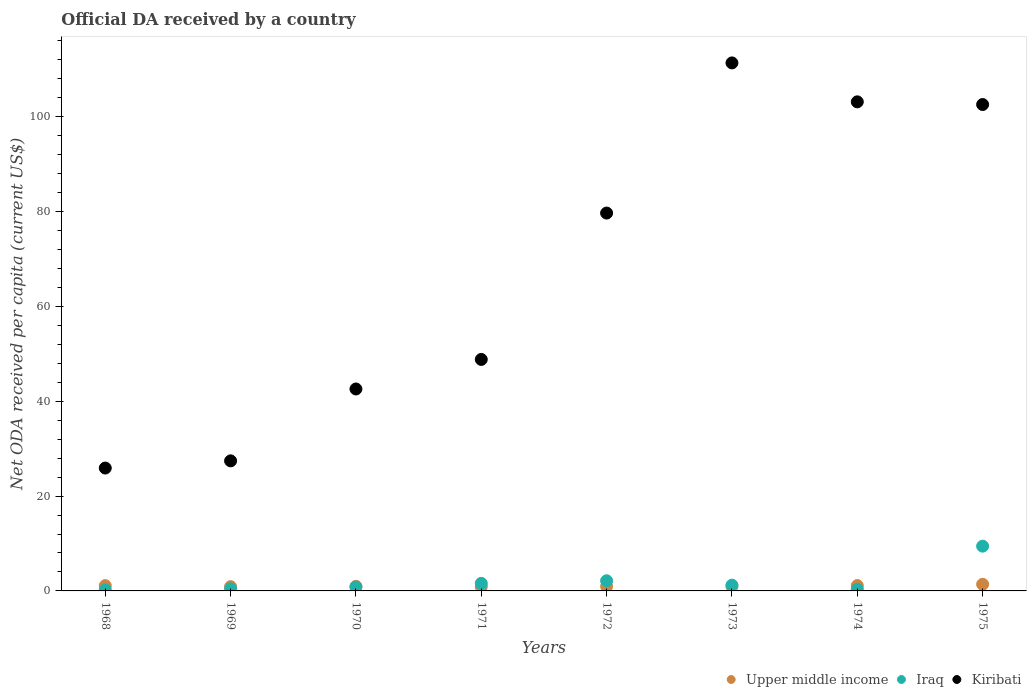How many different coloured dotlines are there?
Your response must be concise. 3. What is the ODA received in in Upper middle income in 1975?
Your response must be concise. 1.39. Across all years, what is the maximum ODA received in in Iraq?
Your response must be concise. 9.44. Across all years, what is the minimum ODA received in in Iraq?
Offer a terse response. 0.25. In which year was the ODA received in in Iraq maximum?
Your answer should be very brief. 1975. In which year was the ODA received in in Iraq minimum?
Your answer should be very brief. 1968. What is the total ODA received in in Kiribati in the graph?
Offer a very short reply. 541.6. What is the difference between the ODA received in in Iraq in 1971 and that in 1975?
Keep it short and to the point. -7.85. What is the difference between the ODA received in in Upper middle income in 1971 and the ODA received in in Kiribati in 1974?
Provide a succinct answer. -102.26. What is the average ODA received in in Upper middle income per year?
Offer a very short reply. 1.04. In the year 1968, what is the difference between the ODA received in in Kiribati and ODA received in in Iraq?
Provide a short and direct response. 25.67. In how many years, is the ODA received in in Iraq greater than 28 US$?
Ensure brevity in your answer.  0. What is the ratio of the ODA received in in Kiribati in 1969 to that in 1973?
Offer a terse response. 0.25. Is the ODA received in in Iraq in 1972 less than that in 1974?
Make the answer very short. No. What is the difference between the highest and the second highest ODA received in in Upper middle income?
Ensure brevity in your answer.  0.26. What is the difference between the highest and the lowest ODA received in in Kiribati?
Keep it short and to the point. 85.45. Does the ODA received in in Upper middle income monotonically increase over the years?
Provide a succinct answer. No. Is the ODA received in in Kiribati strictly greater than the ODA received in in Iraq over the years?
Provide a short and direct response. Yes. How many dotlines are there?
Give a very brief answer. 3. What is the difference between two consecutive major ticks on the Y-axis?
Your answer should be very brief. 20. Does the graph contain grids?
Offer a very short reply. No. Where does the legend appear in the graph?
Provide a succinct answer. Bottom right. How are the legend labels stacked?
Your answer should be compact. Horizontal. What is the title of the graph?
Ensure brevity in your answer.  Official DA received by a country. Does "Turkey" appear as one of the legend labels in the graph?
Ensure brevity in your answer.  No. What is the label or title of the X-axis?
Offer a terse response. Years. What is the label or title of the Y-axis?
Your answer should be compact. Net ODA received per capita (current US$). What is the Net ODA received per capita (current US$) of Upper middle income in 1968?
Your answer should be very brief. 1.12. What is the Net ODA received per capita (current US$) in Iraq in 1968?
Your answer should be compact. 0.25. What is the Net ODA received per capita (current US$) in Kiribati in 1968?
Keep it short and to the point. 25.92. What is the Net ODA received per capita (current US$) in Upper middle income in 1969?
Provide a succinct answer. 0.9. What is the Net ODA received per capita (current US$) in Iraq in 1969?
Your answer should be compact. 0.45. What is the Net ODA received per capita (current US$) of Kiribati in 1969?
Offer a terse response. 27.43. What is the Net ODA received per capita (current US$) in Upper middle income in 1970?
Provide a short and direct response. 0.97. What is the Net ODA received per capita (current US$) in Iraq in 1970?
Make the answer very short. 0.81. What is the Net ODA received per capita (current US$) in Kiribati in 1970?
Ensure brevity in your answer.  42.59. What is the Net ODA received per capita (current US$) in Upper middle income in 1971?
Keep it short and to the point. 0.9. What is the Net ODA received per capita (current US$) of Iraq in 1971?
Make the answer very short. 1.6. What is the Net ODA received per capita (current US$) in Kiribati in 1971?
Provide a short and direct response. 48.83. What is the Net ODA received per capita (current US$) in Upper middle income in 1972?
Give a very brief answer. 0.96. What is the Net ODA received per capita (current US$) of Iraq in 1972?
Offer a very short reply. 2.14. What is the Net ODA received per capita (current US$) in Kiribati in 1972?
Your answer should be very brief. 79.7. What is the Net ODA received per capita (current US$) in Upper middle income in 1973?
Provide a short and direct response. 0.96. What is the Net ODA received per capita (current US$) in Iraq in 1973?
Ensure brevity in your answer.  1.21. What is the Net ODA received per capita (current US$) in Kiribati in 1973?
Make the answer very short. 111.37. What is the Net ODA received per capita (current US$) in Upper middle income in 1974?
Your answer should be very brief. 1.13. What is the Net ODA received per capita (current US$) of Iraq in 1974?
Keep it short and to the point. 0.37. What is the Net ODA received per capita (current US$) in Kiribati in 1974?
Keep it short and to the point. 103.16. What is the Net ODA received per capita (current US$) of Upper middle income in 1975?
Your response must be concise. 1.39. What is the Net ODA received per capita (current US$) of Iraq in 1975?
Your response must be concise. 9.44. What is the Net ODA received per capita (current US$) of Kiribati in 1975?
Offer a terse response. 102.59. Across all years, what is the maximum Net ODA received per capita (current US$) in Upper middle income?
Provide a succinct answer. 1.39. Across all years, what is the maximum Net ODA received per capita (current US$) of Iraq?
Keep it short and to the point. 9.44. Across all years, what is the maximum Net ODA received per capita (current US$) in Kiribati?
Your answer should be compact. 111.37. Across all years, what is the minimum Net ODA received per capita (current US$) of Upper middle income?
Provide a succinct answer. 0.9. Across all years, what is the minimum Net ODA received per capita (current US$) in Iraq?
Ensure brevity in your answer.  0.25. Across all years, what is the minimum Net ODA received per capita (current US$) in Kiribati?
Your response must be concise. 25.92. What is the total Net ODA received per capita (current US$) of Upper middle income in the graph?
Your answer should be very brief. 8.32. What is the total Net ODA received per capita (current US$) of Iraq in the graph?
Your answer should be compact. 16.28. What is the total Net ODA received per capita (current US$) in Kiribati in the graph?
Provide a short and direct response. 541.6. What is the difference between the Net ODA received per capita (current US$) of Upper middle income in 1968 and that in 1969?
Keep it short and to the point. 0.22. What is the difference between the Net ODA received per capita (current US$) in Iraq in 1968 and that in 1969?
Ensure brevity in your answer.  -0.2. What is the difference between the Net ODA received per capita (current US$) of Kiribati in 1968 and that in 1969?
Provide a short and direct response. -1.52. What is the difference between the Net ODA received per capita (current US$) in Upper middle income in 1968 and that in 1970?
Ensure brevity in your answer.  0.15. What is the difference between the Net ODA received per capita (current US$) of Iraq in 1968 and that in 1970?
Give a very brief answer. -0.57. What is the difference between the Net ODA received per capita (current US$) of Kiribati in 1968 and that in 1970?
Your response must be concise. -16.68. What is the difference between the Net ODA received per capita (current US$) of Upper middle income in 1968 and that in 1971?
Give a very brief answer. 0.22. What is the difference between the Net ODA received per capita (current US$) of Iraq in 1968 and that in 1971?
Ensure brevity in your answer.  -1.35. What is the difference between the Net ODA received per capita (current US$) of Kiribati in 1968 and that in 1971?
Offer a very short reply. -22.91. What is the difference between the Net ODA received per capita (current US$) in Upper middle income in 1968 and that in 1972?
Provide a short and direct response. 0.16. What is the difference between the Net ODA received per capita (current US$) of Iraq in 1968 and that in 1972?
Offer a terse response. -1.9. What is the difference between the Net ODA received per capita (current US$) of Kiribati in 1968 and that in 1972?
Your answer should be very brief. -53.78. What is the difference between the Net ODA received per capita (current US$) of Upper middle income in 1968 and that in 1973?
Your answer should be very brief. 0.16. What is the difference between the Net ODA received per capita (current US$) in Iraq in 1968 and that in 1973?
Give a very brief answer. -0.97. What is the difference between the Net ODA received per capita (current US$) of Kiribati in 1968 and that in 1973?
Keep it short and to the point. -85.45. What is the difference between the Net ODA received per capita (current US$) in Upper middle income in 1968 and that in 1974?
Offer a very short reply. -0.02. What is the difference between the Net ODA received per capita (current US$) in Iraq in 1968 and that in 1974?
Give a very brief answer. -0.13. What is the difference between the Net ODA received per capita (current US$) in Kiribati in 1968 and that in 1974?
Provide a short and direct response. -77.24. What is the difference between the Net ODA received per capita (current US$) of Upper middle income in 1968 and that in 1975?
Make the answer very short. -0.28. What is the difference between the Net ODA received per capita (current US$) in Iraq in 1968 and that in 1975?
Your answer should be very brief. -9.2. What is the difference between the Net ODA received per capita (current US$) of Kiribati in 1968 and that in 1975?
Give a very brief answer. -76.68. What is the difference between the Net ODA received per capita (current US$) in Upper middle income in 1969 and that in 1970?
Give a very brief answer. -0.07. What is the difference between the Net ODA received per capita (current US$) of Iraq in 1969 and that in 1970?
Offer a terse response. -0.37. What is the difference between the Net ODA received per capita (current US$) in Kiribati in 1969 and that in 1970?
Offer a very short reply. -15.16. What is the difference between the Net ODA received per capita (current US$) in Upper middle income in 1969 and that in 1971?
Provide a short and direct response. 0. What is the difference between the Net ODA received per capita (current US$) of Iraq in 1969 and that in 1971?
Ensure brevity in your answer.  -1.15. What is the difference between the Net ODA received per capita (current US$) of Kiribati in 1969 and that in 1971?
Provide a short and direct response. -21.39. What is the difference between the Net ODA received per capita (current US$) of Upper middle income in 1969 and that in 1972?
Keep it short and to the point. -0.06. What is the difference between the Net ODA received per capita (current US$) in Iraq in 1969 and that in 1972?
Keep it short and to the point. -1.69. What is the difference between the Net ODA received per capita (current US$) in Kiribati in 1969 and that in 1972?
Provide a short and direct response. -52.27. What is the difference between the Net ODA received per capita (current US$) in Upper middle income in 1969 and that in 1973?
Make the answer very short. -0.06. What is the difference between the Net ODA received per capita (current US$) in Iraq in 1969 and that in 1973?
Your answer should be compact. -0.77. What is the difference between the Net ODA received per capita (current US$) in Kiribati in 1969 and that in 1973?
Your response must be concise. -83.94. What is the difference between the Net ODA received per capita (current US$) of Upper middle income in 1969 and that in 1974?
Offer a terse response. -0.23. What is the difference between the Net ODA received per capita (current US$) of Iraq in 1969 and that in 1974?
Provide a short and direct response. 0.07. What is the difference between the Net ODA received per capita (current US$) in Kiribati in 1969 and that in 1974?
Offer a very short reply. -75.73. What is the difference between the Net ODA received per capita (current US$) in Upper middle income in 1969 and that in 1975?
Your response must be concise. -0.49. What is the difference between the Net ODA received per capita (current US$) in Iraq in 1969 and that in 1975?
Provide a succinct answer. -8.99. What is the difference between the Net ODA received per capita (current US$) of Kiribati in 1969 and that in 1975?
Offer a terse response. -75.16. What is the difference between the Net ODA received per capita (current US$) in Upper middle income in 1970 and that in 1971?
Provide a succinct answer. 0.07. What is the difference between the Net ODA received per capita (current US$) of Iraq in 1970 and that in 1971?
Ensure brevity in your answer.  -0.78. What is the difference between the Net ODA received per capita (current US$) in Kiribati in 1970 and that in 1971?
Your answer should be very brief. -6.23. What is the difference between the Net ODA received per capita (current US$) in Upper middle income in 1970 and that in 1972?
Provide a succinct answer. 0.01. What is the difference between the Net ODA received per capita (current US$) of Iraq in 1970 and that in 1972?
Your response must be concise. -1.33. What is the difference between the Net ODA received per capita (current US$) in Kiribati in 1970 and that in 1972?
Make the answer very short. -37.11. What is the difference between the Net ODA received per capita (current US$) of Upper middle income in 1970 and that in 1973?
Ensure brevity in your answer.  0.01. What is the difference between the Net ODA received per capita (current US$) in Iraq in 1970 and that in 1973?
Make the answer very short. -0.4. What is the difference between the Net ODA received per capita (current US$) of Kiribati in 1970 and that in 1973?
Make the answer very short. -68.78. What is the difference between the Net ODA received per capita (current US$) in Upper middle income in 1970 and that in 1974?
Your answer should be compact. -0.17. What is the difference between the Net ODA received per capita (current US$) of Iraq in 1970 and that in 1974?
Provide a short and direct response. 0.44. What is the difference between the Net ODA received per capita (current US$) in Kiribati in 1970 and that in 1974?
Give a very brief answer. -60.57. What is the difference between the Net ODA received per capita (current US$) of Upper middle income in 1970 and that in 1975?
Keep it short and to the point. -0.43. What is the difference between the Net ODA received per capita (current US$) of Iraq in 1970 and that in 1975?
Offer a very short reply. -8.63. What is the difference between the Net ODA received per capita (current US$) in Kiribati in 1970 and that in 1975?
Your answer should be compact. -60. What is the difference between the Net ODA received per capita (current US$) of Upper middle income in 1971 and that in 1972?
Your answer should be compact. -0.06. What is the difference between the Net ODA received per capita (current US$) in Iraq in 1971 and that in 1972?
Your response must be concise. -0.55. What is the difference between the Net ODA received per capita (current US$) of Kiribati in 1971 and that in 1972?
Your answer should be compact. -30.87. What is the difference between the Net ODA received per capita (current US$) of Upper middle income in 1971 and that in 1973?
Your answer should be very brief. -0.06. What is the difference between the Net ODA received per capita (current US$) in Iraq in 1971 and that in 1973?
Your answer should be very brief. 0.38. What is the difference between the Net ODA received per capita (current US$) in Kiribati in 1971 and that in 1973?
Ensure brevity in your answer.  -62.54. What is the difference between the Net ODA received per capita (current US$) of Upper middle income in 1971 and that in 1974?
Give a very brief answer. -0.23. What is the difference between the Net ODA received per capita (current US$) of Iraq in 1971 and that in 1974?
Offer a terse response. 1.22. What is the difference between the Net ODA received per capita (current US$) in Kiribati in 1971 and that in 1974?
Keep it short and to the point. -54.33. What is the difference between the Net ODA received per capita (current US$) in Upper middle income in 1971 and that in 1975?
Ensure brevity in your answer.  -0.5. What is the difference between the Net ODA received per capita (current US$) of Iraq in 1971 and that in 1975?
Provide a short and direct response. -7.85. What is the difference between the Net ODA received per capita (current US$) in Kiribati in 1971 and that in 1975?
Offer a terse response. -53.77. What is the difference between the Net ODA received per capita (current US$) in Upper middle income in 1972 and that in 1973?
Offer a very short reply. 0. What is the difference between the Net ODA received per capita (current US$) in Iraq in 1972 and that in 1973?
Offer a very short reply. 0.93. What is the difference between the Net ODA received per capita (current US$) in Kiribati in 1972 and that in 1973?
Your answer should be compact. -31.67. What is the difference between the Net ODA received per capita (current US$) in Upper middle income in 1972 and that in 1974?
Provide a succinct answer. -0.17. What is the difference between the Net ODA received per capita (current US$) in Iraq in 1972 and that in 1974?
Ensure brevity in your answer.  1.77. What is the difference between the Net ODA received per capita (current US$) of Kiribati in 1972 and that in 1974?
Make the answer very short. -23.46. What is the difference between the Net ODA received per capita (current US$) in Upper middle income in 1972 and that in 1975?
Provide a short and direct response. -0.44. What is the difference between the Net ODA received per capita (current US$) of Iraq in 1972 and that in 1975?
Make the answer very short. -7.3. What is the difference between the Net ODA received per capita (current US$) of Kiribati in 1972 and that in 1975?
Provide a succinct answer. -22.89. What is the difference between the Net ODA received per capita (current US$) in Upper middle income in 1973 and that in 1974?
Ensure brevity in your answer.  -0.17. What is the difference between the Net ODA received per capita (current US$) in Iraq in 1973 and that in 1974?
Your answer should be compact. 0.84. What is the difference between the Net ODA received per capita (current US$) in Kiribati in 1973 and that in 1974?
Your response must be concise. 8.21. What is the difference between the Net ODA received per capita (current US$) in Upper middle income in 1973 and that in 1975?
Your response must be concise. -0.44. What is the difference between the Net ODA received per capita (current US$) in Iraq in 1973 and that in 1975?
Keep it short and to the point. -8.23. What is the difference between the Net ODA received per capita (current US$) of Kiribati in 1973 and that in 1975?
Make the answer very short. 8.78. What is the difference between the Net ODA received per capita (current US$) in Upper middle income in 1974 and that in 1975?
Provide a short and direct response. -0.26. What is the difference between the Net ODA received per capita (current US$) of Iraq in 1974 and that in 1975?
Give a very brief answer. -9.07. What is the difference between the Net ODA received per capita (current US$) of Kiribati in 1974 and that in 1975?
Offer a very short reply. 0.57. What is the difference between the Net ODA received per capita (current US$) of Upper middle income in 1968 and the Net ODA received per capita (current US$) of Iraq in 1969?
Your answer should be compact. 0.67. What is the difference between the Net ODA received per capita (current US$) in Upper middle income in 1968 and the Net ODA received per capita (current US$) in Kiribati in 1969?
Keep it short and to the point. -26.32. What is the difference between the Net ODA received per capita (current US$) in Iraq in 1968 and the Net ODA received per capita (current US$) in Kiribati in 1969?
Give a very brief answer. -27.19. What is the difference between the Net ODA received per capita (current US$) in Upper middle income in 1968 and the Net ODA received per capita (current US$) in Iraq in 1970?
Provide a short and direct response. 0.3. What is the difference between the Net ODA received per capita (current US$) of Upper middle income in 1968 and the Net ODA received per capita (current US$) of Kiribati in 1970?
Your answer should be compact. -41.48. What is the difference between the Net ODA received per capita (current US$) in Iraq in 1968 and the Net ODA received per capita (current US$) in Kiribati in 1970?
Make the answer very short. -42.35. What is the difference between the Net ODA received per capita (current US$) of Upper middle income in 1968 and the Net ODA received per capita (current US$) of Iraq in 1971?
Your answer should be very brief. -0.48. What is the difference between the Net ODA received per capita (current US$) of Upper middle income in 1968 and the Net ODA received per capita (current US$) of Kiribati in 1971?
Keep it short and to the point. -47.71. What is the difference between the Net ODA received per capita (current US$) of Iraq in 1968 and the Net ODA received per capita (current US$) of Kiribati in 1971?
Keep it short and to the point. -48.58. What is the difference between the Net ODA received per capita (current US$) in Upper middle income in 1968 and the Net ODA received per capita (current US$) in Iraq in 1972?
Your answer should be compact. -1.03. What is the difference between the Net ODA received per capita (current US$) in Upper middle income in 1968 and the Net ODA received per capita (current US$) in Kiribati in 1972?
Offer a terse response. -78.58. What is the difference between the Net ODA received per capita (current US$) of Iraq in 1968 and the Net ODA received per capita (current US$) of Kiribati in 1972?
Give a very brief answer. -79.45. What is the difference between the Net ODA received per capita (current US$) of Upper middle income in 1968 and the Net ODA received per capita (current US$) of Iraq in 1973?
Ensure brevity in your answer.  -0.1. What is the difference between the Net ODA received per capita (current US$) of Upper middle income in 1968 and the Net ODA received per capita (current US$) of Kiribati in 1973?
Give a very brief answer. -110.25. What is the difference between the Net ODA received per capita (current US$) of Iraq in 1968 and the Net ODA received per capita (current US$) of Kiribati in 1973?
Make the answer very short. -111.12. What is the difference between the Net ODA received per capita (current US$) of Upper middle income in 1968 and the Net ODA received per capita (current US$) of Iraq in 1974?
Your answer should be compact. 0.74. What is the difference between the Net ODA received per capita (current US$) of Upper middle income in 1968 and the Net ODA received per capita (current US$) of Kiribati in 1974?
Your answer should be compact. -102.04. What is the difference between the Net ODA received per capita (current US$) of Iraq in 1968 and the Net ODA received per capita (current US$) of Kiribati in 1974?
Keep it short and to the point. -102.91. What is the difference between the Net ODA received per capita (current US$) in Upper middle income in 1968 and the Net ODA received per capita (current US$) in Iraq in 1975?
Your answer should be very brief. -8.33. What is the difference between the Net ODA received per capita (current US$) in Upper middle income in 1968 and the Net ODA received per capita (current US$) in Kiribati in 1975?
Your response must be concise. -101.48. What is the difference between the Net ODA received per capita (current US$) of Iraq in 1968 and the Net ODA received per capita (current US$) of Kiribati in 1975?
Keep it short and to the point. -102.35. What is the difference between the Net ODA received per capita (current US$) in Upper middle income in 1969 and the Net ODA received per capita (current US$) in Iraq in 1970?
Your answer should be very brief. 0.09. What is the difference between the Net ODA received per capita (current US$) of Upper middle income in 1969 and the Net ODA received per capita (current US$) of Kiribati in 1970?
Your answer should be very brief. -41.69. What is the difference between the Net ODA received per capita (current US$) of Iraq in 1969 and the Net ODA received per capita (current US$) of Kiribati in 1970?
Keep it short and to the point. -42.15. What is the difference between the Net ODA received per capita (current US$) of Upper middle income in 1969 and the Net ODA received per capita (current US$) of Iraq in 1971?
Your response must be concise. -0.7. What is the difference between the Net ODA received per capita (current US$) in Upper middle income in 1969 and the Net ODA received per capita (current US$) in Kiribati in 1971?
Offer a very short reply. -47.93. What is the difference between the Net ODA received per capita (current US$) of Iraq in 1969 and the Net ODA received per capita (current US$) of Kiribati in 1971?
Ensure brevity in your answer.  -48.38. What is the difference between the Net ODA received per capita (current US$) in Upper middle income in 1969 and the Net ODA received per capita (current US$) in Iraq in 1972?
Offer a terse response. -1.24. What is the difference between the Net ODA received per capita (current US$) in Upper middle income in 1969 and the Net ODA received per capita (current US$) in Kiribati in 1972?
Keep it short and to the point. -78.8. What is the difference between the Net ODA received per capita (current US$) of Iraq in 1969 and the Net ODA received per capita (current US$) of Kiribati in 1972?
Offer a very short reply. -79.25. What is the difference between the Net ODA received per capita (current US$) in Upper middle income in 1969 and the Net ODA received per capita (current US$) in Iraq in 1973?
Provide a short and direct response. -0.32. What is the difference between the Net ODA received per capita (current US$) in Upper middle income in 1969 and the Net ODA received per capita (current US$) in Kiribati in 1973?
Keep it short and to the point. -110.47. What is the difference between the Net ODA received per capita (current US$) of Iraq in 1969 and the Net ODA received per capita (current US$) of Kiribati in 1973?
Your answer should be very brief. -110.92. What is the difference between the Net ODA received per capita (current US$) in Upper middle income in 1969 and the Net ODA received per capita (current US$) in Iraq in 1974?
Your answer should be very brief. 0.53. What is the difference between the Net ODA received per capita (current US$) of Upper middle income in 1969 and the Net ODA received per capita (current US$) of Kiribati in 1974?
Keep it short and to the point. -102.26. What is the difference between the Net ODA received per capita (current US$) in Iraq in 1969 and the Net ODA received per capita (current US$) in Kiribati in 1974?
Offer a terse response. -102.71. What is the difference between the Net ODA received per capita (current US$) of Upper middle income in 1969 and the Net ODA received per capita (current US$) of Iraq in 1975?
Your answer should be compact. -8.54. What is the difference between the Net ODA received per capita (current US$) in Upper middle income in 1969 and the Net ODA received per capita (current US$) in Kiribati in 1975?
Give a very brief answer. -101.69. What is the difference between the Net ODA received per capita (current US$) in Iraq in 1969 and the Net ODA received per capita (current US$) in Kiribati in 1975?
Your answer should be compact. -102.15. What is the difference between the Net ODA received per capita (current US$) in Upper middle income in 1970 and the Net ODA received per capita (current US$) in Iraq in 1971?
Offer a terse response. -0.63. What is the difference between the Net ODA received per capita (current US$) of Upper middle income in 1970 and the Net ODA received per capita (current US$) of Kiribati in 1971?
Offer a very short reply. -47.86. What is the difference between the Net ODA received per capita (current US$) of Iraq in 1970 and the Net ODA received per capita (current US$) of Kiribati in 1971?
Your answer should be very brief. -48.01. What is the difference between the Net ODA received per capita (current US$) of Upper middle income in 1970 and the Net ODA received per capita (current US$) of Iraq in 1972?
Offer a very short reply. -1.18. What is the difference between the Net ODA received per capita (current US$) in Upper middle income in 1970 and the Net ODA received per capita (current US$) in Kiribati in 1972?
Keep it short and to the point. -78.73. What is the difference between the Net ODA received per capita (current US$) of Iraq in 1970 and the Net ODA received per capita (current US$) of Kiribati in 1972?
Your answer should be compact. -78.89. What is the difference between the Net ODA received per capita (current US$) of Upper middle income in 1970 and the Net ODA received per capita (current US$) of Iraq in 1973?
Your answer should be compact. -0.25. What is the difference between the Net ODA received per capita (current US$) of Upper middle income in 1970 and the Net ODA received per capita (current US$) of Kiribati in 1973?
Make the answer very short. -110.4. What is the difference between the Net ODA received per capita (current US$) of Iraq in 1970 and the Net ODA received per capita (current US$) of Kiribati in 1973?
Make the answer very short. -110.56. What is the difference between the Net ODA received per capita (current US$) of Upper middle income in 1970 and the Net ODA received per capita (current US$) of Iraq in 1974?
Your answer should be very brief. 0.59. What is the difference between the Net ODA received per capita (current US$) in Upper middle income in 1970 and the Net ODA received per capita (current US$) in Kiribati in 1974?
Give a very brief answer. -102.19. What is the difference between the Net ODA received per capita (current US$) in Iraq in 1970 and the Net ODA received per capita (current US$) in Kiribati in 1974?
Offer a very short reply. -102.35. What is the difference between the Net ODA received per capita (current US$) of Upper middle income in 1970 and the Net ODA received per capita (current US$) of Iraq in 1975?
Your answer should be very brief. -8.48. What is the difference between the Net ODA received per capita (current US$) of Upper middle income in 1970 and the Net ODA received per capita (current US$) of Kiribati in 1975?
Your answer should be compact. -101.63. What is the difference between the Net ODA received per capita (current US$) of Iraq in 1970 and the Net ODA received per capita (current US$) of Kiribati in 1975?
Provide a short and direct response. -101.78. What is the difference between the Net ODA received per capita (current US$) in Upper middle income in 1971 and the Net ODA received per capita (current US$) in Iraq in 1972?
Offer a terse response. -1.24. What is the difference between the Net ODA received per capita (current US$) in Upper middle income in 1971 and the Net ODA received per capita (current US$) in Kiribati in 1972?
Your response must be concise. -78.8. What is the difference between the Net ODA received per capita (current US$) in Iraq in 1971 and the Net ODA received per capita (current US$) in Kiribati in 1972?
Your response must be concise. -78.11. What is the difference between the Net ODA received per capita (current US$) in Upper middle income in 1971 and the Net ODA received per capita (current US$) in Iraq in 1973?
Ensure brevity in your answer.  -0.32. What is the difference between the Net ODA received per capita (current US$) in Upper middle income in 1971 and the Net ODA received per capita (current US$) in Kiribati in 1973?
Provide a succinct answer. -110.47. What is the difference between the Net ODA received per capita (current US$) of Iraq in 1971 and the Net ODA received per capita (current US$) of Kiribati in 1973?
Your response must be concise. -109.78. What is the difference between the Net ODA received per capita (current US$) in Upper middle income in 1971 and the Net ODA received per capita (current US$) in Iraq in 1974?
Give a very brief answer. 0.52. What is the difference between the Net ODA received per capita (current US$) of Upper middle income in 1971 and the Net ODA received per capita (current US$) of Kiribati in 1974?
Offer a terse response. -102.26. What is the difference between the Net ODA received per capita (current US$) in Iraq in 1971 and the Net ODA received per capita (current US$) in Kiribati in 1974?
Offer a very short reply. -101.56. What is the difference between the Net ODA received per capita (current US$) in Upper middle income in 1971 and the Net ODA received per capita (current US$) in Iraq in 1975?
Your response must be concise. -8.54. What is the difference between the Net ODA received per capita (current US$) in Upper middle income in 1971 and the Net ODA received per capita (current US$) in Kiribati in 1975?
Provide a short and direct response. -101.7. What is the difference between the Net ODA received per capita (current US$) of Iraq in 1971 and the Net ODA received per capita (current US$) of Kiribati in 1975?
Offer a very short reply. -101. What is the difference between the Net ODA received per capita (current US$) of Upper middle income in 1972 and the Net ODA received per capita (current US$) of Iraq in 1973?
Give a very brief answer. -0.26. What is the difference between the Net ODA received per capita (current US$) in Upper middle income in 1972 and the Net ODA received per capita (current US$) in Kiribati in 1973?
Ensure brevity in your answer.  -110.41. What is the difference between the Net ODA received per capita (current US$) in Iraq in 1972 and the Net ODA received per capita (current US$) in Kiribati in 1973?
Provide a short and direct response. -109.23. What is the difference between the Net ODA received per capita (current US$) in Upper middle income in 1972 and the Net ODA received per capita (current US$) in Iraq in 1974?
Provide a succinct answer. 0.58. What is the difference between the Net ODA received per capita (current US$) in Upper middle income in 1972 and the Net ODA received per capita (current US$) in Kiribati in 1974?
Give a very brief answer. -102.2. What is the difference between the Net ODA received per capita (current US$) of Iraq in 1972 and the Net ODA received per capita (current US$) of Kiribati in 1974?
Your answer should be very brief. -101.02. What is the difference between the Net ODA received per capita (current US$) of Upper middle income in 1972 and the Net ODA received per capita (current US$) of Iraq in 1975?
Make the answer very short. -8.49. What is the difference between the Net ODA received per capita (current US$) in Upper middle income in 1972 and the Net ODA received per capita (current US$) in Kiribati in 1975?
Ensure brevity in your answer.  -101.64. What is the difference between the Net ODA received per capita (current US$) of Iraq in 1972 and the Net ODA received per capita (current US$) of Kiribati in 1975?
Offer a terse response. -100.45. What is the difference between the Net ODA received per capita (current US$) of Upper middle income in 1973 and the Net ODA received per capita (current US$) of Iraq in 1974?
Your response must be concise. 0.58. What is the difference between the Net ODA received per capita (current US$) in Upper middle income in 1973 and the Net ODA received per capita (current US$) in Kiribati in 1974?
Offer a terse response. -102.2. What is the difference between the Net ODA received per capita (current US$) in Iraq in 1973 and the Net ODA received per capita (current US$) in Kiribati in 1974?
Your response must be concise. -101.94. What is the difference between the Net ODA received per capita (current US$) of Upper middle income in 1973 and the Net ODA received per capita (current US$) of Iraq in 1975?
Your answer should be compact. -8.49. What is the difference between the Net ODA received per capita (current US$) of Upper middle income in 1973 and the Net ODA received per capita (current US$) of Kiribati in 1975?
Your answer should be compact. -101.64. What is the difference between the Net ODA received per capita (current US$) of Iraq in 1973 and the Net ODA received per capita (current US$) of Kiribati in 1975?
Make the answer very short. -101.38. What is the difference between the Net ODA received per capita (current US$) of Upper middle income in 1974 and the Net ODA received per capita (current US$) of Iraq in 1975?
Provide a succinct answer. -8.31. What is the difference between the Net ODA received per capita (current US$) of Upper middle income in 1974 and the Net ODA received per capita (current US$) of Kiribati in 1975?
Your answer should be compact. -101.46. What is the difference between the Net ODA received per capita (current US$) in Iraq in 1974 and the Net ODA received per capita (current US$) in Kiribati in 1975?
Provide a short and direct response. -102.22. What is the average Net ODA received per capita (current US$) in Upper middle income per year?
Your answer should be compact. 1.04. What is the average Net ODA received per capita (current US$) in Iraq per year?
Offer a very short reply. 2.03. What is the average Net ODA received per capita (current US$) in Kiribati per year?
Provide a succinct answer. 67.7. In the year 1968, what is the difference between the Net ODA received per capita (current US$) in Upper middle income and Net ODA received per capita (current US$) in Iraq?
Provide a succinct answer. 0.87. In the year 1968, what is the difference between the Net ODA received per capita (current US$) of Upper middle income and Net ODA received per capita (current US$) of Kiribati?
Offer a very short reply. -24.8. In the year 1968, what is the difference between the Net ODA received per capita (current US$) of Iraq and Net ODA received per capita (current US$) of Kiribati?
Your response must be concise. -25.67. In the year 1969, what is the difference between the Net ODA received per capita (current US$) in Upper middle income and Net ODA received per capita (current US$) in Iraq?
Offer a very short reply. 0.45. In the year 1969, what is the difference between the Net ODA received per capita (current US$) of Upper middle income and Net ODA received per capita (current US$) of Kiribati?
Provide a short and direct response. -26.53. In the year 1969, what is the difference between the Net ODA received per capita (current US$) of Iraq and Net ODA received per capita (current US$) of Kiribati?
Provide a succinct answer. -26.99. In the year 1970, what is the difference between the Net ODA received per capita (current US$) in Upper middle income and Net ODA received per capita (current US$) in Iraq?
Offer a terse response. 0.15. In the year 1970, what is the difference between the Net ODA received per capita (current US$) of Upper middle income and Net ODA received per capita (current US$) of Kiribati?
Give a very brief answer. -41.63. In the year 1970, what is the difference between the Net ODA received per capita (current US$) of Iraq and Net ODA received per capita (current US$) of Kiribati?
Your response must be concise. -41.78. In the year 1971, what is the difference between the Net ODA received per capita (current US$) of Upper middle income and Net ODA received per capita (current US$) of Iraq?
Your answer should be very brief. -0.7. In the year 1971, what is the difference between the Net ODA received per capita (current US$) in Upper middle income and Net ODA received per capita (current US$) in Kiribati?
Your answer should be compact. -47.93. In the year 1971, what is the difference between the Net ODA received per capita (current US$) of Iraq and Net ODA received per capita (current US$) of Kiribati?
Your answer should be compact. -47.23. In the year 1972, what is the difference between the Net ODA received per capita (current US$) of Upper middle income and Net ODA received per capita (current US$) of Iraq?
Offer a very short reply. -1.19. In the year 1972, what is the difference between the Net ODA received per capita (current US$) of Upper middle income and Net ODA received per capita (current US$) of Kiribati?
Provide a short and direct response. -78.74. In the year 1972, what is the difference between the Net ODA received per capita (current US$) of Iraq and Net ODA received per capita (current US$) of Kiribati?
Provide a succinct answer. -77.56. In the year 1973, what is the difference between the Net ODA received per capita (current US$) of Upper middle income and Net ODA received per capita (current US$) of Iraq?
Your response must be concise. -0.26. In the year 1973, what is the difference between the Net ODA received per capita (current US$) in Upper middle income and Net ODA received per capita (current US$) in Kiribati?
Your response must be concise. -110.41. In the year 1973, what is the difference between the Net ODA received per capita (current US$) of Iraq and Net ODA received per capita (current US$) of Kiribati?
Keep it short and to the point. -110.16. In the year 1974, what is the difference between the Net ODA received per capita (current US$) in Upper middle income and Net ODA received per capita (current US$) in Iraq?
Give a very brief answer. 0.76. In the year 1974, what is the difference between the Net ODA received per capita (current US$) in Upper middle income and Net ODA received per capita (current US$) in Kiribati?
Offer a terse response. -102.03. In the year 1974, what is the difference between the Net ODA received per capita (current US$) in Iraq and Net ODA received per capita (current US$) in Kiribati?
Provide a succinct answer. -102.79. In the year 1975, what is the difference between the Net ODA received per capita (current US$) in Upper middle income and Net ODA received per capita (current US$) in Iraq?
Make the answer very short. -8.05. In the year 1975, what is the difference between the Net ODA received per capita (current US$) in Upper middle income and Net ODA received per capita (current US$) in Kiribati?
Give a very brief answer. -101.2. In the year 1975, what is the difference between the Net ODA received per capita (current US$) of Iraq and Net ODA received per capita (current US$) of Kiribati?
Provide a succinct answer. -93.15. What is the ratio of the Net ODA received per capita (current US$) in Upper middle income in 1968 to that in 1969?
Provide a succinct answer. 1.24. What is the ratio of the Net ODA received per capita (current US$) in Iraq in 1968 to that in 1969?
Provide a succinct answer. 0.55. What is the ratio of the Net ODA received per capita (current US$) of Kiribati in 1968 to that in 1969?
Your response must be concise. 0.94. What is the ratio of the Net ODA received per capita (current US$) in Upper middle income in 1968 to that in 1970?
Your answer should be very brief. 1.16. What is the ratio of the Net ODA received per capita (current US$) of Iraq in 1968 to that in 1970?
Give a very brief answer. 0.3. What is the ratio of the Net ODA received per capita (current US$) of Kiribati in 1968 to that in 1970?
Provide a short and direct response. 0.61. What is the ratio of the Net ODA received per capita (current US$) in Upper middle income in 1968 to that in 1971?
Offer a terse response. 1.24. What is the ratio of the Net ODA received per capita (current US$) in Iraq in 1968 to that in 1971?
Keep it short and to the point. 0.15. What is the ratio of the Net ODA received per capita (current US$) in Kiribati in 1968 to that in 1971?
Offer a terse response. 0.53. What is the ratio of the Net ODA received per capita (current US$) of Upper middle income in 1968 to that in 1972?
Your answer should be compact. 1.17. What is the ratio of the Net ODA received per capita (current US$) in Iraq in 1968 to that in 1972?
Offer a terse response. 0.12. What is the ratio of the Net ODA received per capita (current US$) in Kiribati in 1968 to that in 1972?
Make the answer very short. 0.33. What is the ratio of the Net ODA received per capita (current US$) in Upper middle income in 1968 to that in 1973?
Give a very brief answer. 1.17. What is the ratio of the Net ODA received per capita (current US$) in Iraq in 1968 to that in 1973?
Provide a short and direct response. 0.2. What is the ratio of the Net ODA received per capita (current US$) in Kiribati in 1968 to that in 1973?
Your answer should be compact. 0.23. What is the ratio of the Net ODA received per capita (current US$) of Upper middle income in 1968 to that in 1974?
Make the answer very short. 0.99. What is the ratio of the Net ODA received per capita (current US$) in Iraq in 1968 to that in 1974?
Offer a terse response. 0.66. What is the ratio of the Net ODA received per capita (current US$) of Kiribati in 1968 to that in 1974?
Give a very brief answer. 0.25. What is the ratio of the Net ODA received per capita (current US$) of Upper middle income in 1968 to that in 1975?
Your answer should be very brief. 0.8. What is the ratio of the Net ODA received per capita (current US$) of Iraq in 1968 to that in 1975?
Your answer should be compact. 0.03. What is the ratio of the Net ODA received per capita (current US$) of Kiribati in 1968 to that in 1975?
Your answer should be compact. 0.25. What is the ratio of the Net ODA received per capita (current US$) of Upper middle income in 1969 to that in 1970?
Your response must be concise. 0.93. What is the ratio of the Net ODA received per capita (current US$) of Iraq in 1969 to that in 1970?
Keep it short and to the point. 0.55. What is the ratio of the Net ODA received per capita (current US$) of Kiribati in 1969 to that in 1970?
Keep it short and to the point. 0.64. What is the ratio of the Net ODA received per capita (current US$) of Iraq in 1969 to that in 1971?
Provide a succinct answer. 0.28. What is the ratio of the Net ODA received per capita (current US$) in Kiribati in 1969 to that in 1971?
Ensure brevity in your answer.  0.56. What is the ratio of the Net ODA received per capita (current US$) of Upper middle income in 1969 to that in 1972?
Make the answer very short. 0.94. What is the ratio of the Net ODA received per capita (current US$) of Iraq in 1969 to that in 1972?
Ensure brevity in your answer.  0.21. What is the ratio of the Net ODA received per capita (current US$) in Kiribati in 1969 to that in 1972?
Make the answer very short. 0.34. What is the ratio of the Net ODA received per capita (current US$) in Upper middle income in 1969 to that in 1973?
Offer a terse response. 0.94. What is the ratio of the Net ODA received per capita (current US$) in Iraq in 1969 to that in 1973?
Offer a very short reply. 0.37. What is the ratio of the Net ODA received per capita (current US$) of Kiribati in 1969 to that in 1973?
Your answer should be very brief. 0.25. What is the ratio of the Net ODA received per capita (current US$) of Upper middle income in 1969 to that in 1974?
Provide a short and direct response. 0.8. What is the ratio of the Net ODA received per capita (current US$) of Iraq in 1969 to that in 1974?
Ensure brevity in your answer.  1.2. What is the ratio of the Net ODA received per capita (current US$) of Kiribati in 1969 to that in 1974?
Provide a short and direct response. 0.27. What is the ratio of the Net ODA received per capita (current US$) in Upper middle income in 1969 to that in 1975?
Offer a terse response. 0.65. What is the ratio of the Net ODA received per capita (current US$) in Iraq in 1969 to that in 1975?
Your response must be concise. 0.05. What is the ratio of the Net ODA received per capita (current US$) of Kiribati in 1969 to that in 1975?
Provide a succinct answer. 0.27. What is the ratio of the Net ODA received per capita (current US$) of Upper middle income in 1970 to that in 1971?
Make the answer very short. 1.08. What is the ratio of the Net ODA received per capita (current US$) of Iraq in 1970 to that in 1971?
Your answer should be compact. 0.51. What is the ratio of the Net ODA received per capita (current US$) in Kiribati in 1970 to that in 1971?
Give a very brief answer. 0.87. What is the ratio of the Net ODA received per capita (current US$) in Upper middle income in 1970 to that in 1972?
Keep it short and to the point. 1.01. What is the ratio of the Net ODA received per capita (current US$) of Iraq in 1970 to that in 1972?
Give a very brief answer. 0.38. What is the ratio of the Net ODA received per capita (current US$) of Kiribati in 1970 to that in 1972?
Provide a succinct answer. 0.53. What is the ratio of the Net ODA received per capita (current US$) of Upper middle income in 1970 to that in 1973?
Ensure brevity in your answer.  1.01. What is the ratio of the Net ODA received per capita (current US$) in Iraq in 1970 to that in 1973?
Your response must be concise. 0.67. What is the ratio of the Net ODA received per capita (current US$) of Kiribati in 1970 to that in 1973?
Your answer should be compact. 0.38. What is the ratio of the Net ODA received per capita (current US$) in Upper middle income in 1970 to that in 1974?
Your answer should be very brief. 0.85. What is the ratio of the Net ODA received per capita (current US$) in Iraq in 1970 to that in 1974?
Provide a succinct answer. 2.17. What is the ratio of the Net ODA received per capita (current US$) of Kiribati in 1970 to that in 1974?
Your response must be concise. 0.41. What is the ratio of the Net ODA received per capita (current US$) of Upper middle income in 1970 to that in 1975?
Offer a very short reply. 0.69. What is the ratio of the Net ODA received per capita (current US$) in Iraq in 1970 to that in 1975?
Your response must be concise. 0.09. What is the ratio of the Net ODA received per capita (current US$) in Kiribati in 1970 to that in 1975?
Give a very brief answer. 0.42. What is the ratio of the Net ODA received per capita (current US$) in Upper middle income in 1971 to that in 1972?
Ensure brevity in your answer.  0.94. What is the ratio of the Net ODA received per capita (current US$) of Iraq in 1971 to that in 1972?
Make the answer very short. 0.74. What is the ratio of the Net ODA received per capita (current US$) of Kiribati in 1971 to that in 1972?
Offer a terse response. 0.61. What is the ratio of the Net ODA received per capita (current US$) in Upper middle income in 1971 to that in 1973?
Your answer should be very brief. 0.94. What is the ratio of the Net ODA received per capita (current US$) of Iraq in 1971 to that in 1973?
Make the answer very short. 1.31. What is the ratio of the Net ODA received per capita (current US$) in Kiribati in 1971 to that in 1973?
Ensure brevity in your answer.  0.44. What is the ratio of the Net ODA received per capita (current US$) in Upper middle income in 1971 to that in 1974?
Offer a terse response. 0.79. What is the ratio of the Net ODA received per capita (current US$) in Iraq in 1971 to that in 1974?
Your response must be concise. 4.27. What is the ratio of the Net ODA received per capita (current US$) of Kiribati in 1971 to that in 1974?
Keep it short and to the point. 0.47. What is the ratio of the Net ODA received per capita (current US$) in Upper middle income in 1971 to that in 1975?
Keep it short and to the point. 0.64. What is the ratio of the Net ODA received per capita (current US$) in Iraq in 1971 to that in 1975?
Keep it short and to the point. 0.17. What is the ratio of the Net ODA received per capita (current US$) in Kiribati in 1971 to that in 1975?
Offer a very short reply. 0.48. What is the ratio of the Net ODA received per capita (current US$) of Upper middle income in 1972 to that in 1973?
Offer a terse response. 1. What is the ratio of the Net ODA received per capita (current US$) of Iraq in 1972 to that in 1973?
Your answer should be compact. 1.76. What is the ratio of the Net ODA received per capita (current US$) in Kiribati in 1972 to that in 1973?
Offer a very short reply. 0.72. What is the ratio of the Net ODA received per capita (current US$) in Upper middle income in 1972 to that in 1974?
Provide a succinct answer. 0.85. What is the ratio of the Net ODA received per capita (current US$) in Iraq in 1972 to that in 1974?
Your response must be concise. 5.73. What is the ratio of the Net ODA received per capita (current US$) of Kiribati in 1972 to that in 1974?
Your answer should be very brief. 0.77. What is the ratio of the Net ODA received per capita (current US$) of Upper middle income in 1972 to that in 1975?
Keep it short and to the point. 0.69. What is the ratio of the Net ODA received per capita (current US$) of Iraq in 1972 to that in 1975?
Your answer should be very brief. 0.23. What is the ratio of the Net ODA received per capita (current US$) in Kiribati in 1972 to that in 1975?
Make the answer very short. 0.78. What is the ratio of the Net ODA received per capita (current US$) in Upper middle income in 1973 to that in 1974?
Provide a succinct answer. 0.85. What is the ratio of the Net ODA received per capita (current US$) of Iraq in 1973 to that in 1974?
Offer a very short reply. 3.25. What is the ratio of the Net ODA received per capita (current US$) of Kiribati in 1973 to that in 1974?
Offer a terse response. 1.08. What is the ratio of the Net ODA received per capita (current US$) in Upper middle income in 1973 to that in 1975?
Provide a short and direct response. 0.69. What is the ratio of the Net ODA received per capita (current US$) in Iraq in 1973 to that in 1975?
Your answer should be very brief. 0.13. What is the ratio of the Net ODA received per capita (current US$) in Kiribati in 1973 to that in 1975?
Provide a succinct answer. 1.09. What is the ratio of the Net ODA received per capita (current US$) in Upper middle income in 1974 to that in 1975?
Provide a succinct answer. 0.81. What is the ratio of the Net ODA received per capita (current US$) in Iraq in 1974 to that in 1975?
Offer a very short reply. 0.04. What is the difference between the highest and the second highest Net ODA received per capita (current US$) of Upper middle income?
Ensure brevity in your answer.  0.26. What is the difference between the highest and the second highest Net ODA received per capita (current US$) in Iraq?
Give a very brief answer. 7.3. What is the difference between the highest and the second highest Net ODA received per capita (current US$) in Kiribati?
Your response must be concise. 8.21. What is the difference between the highest and the lowest Net ODA received per capita (current US$) of Upper middle income?
Your answer should be very brief. 0.5. What is the difference between the highest and the lowest Net ODA received per capita (current US$) in Iraq?
Keep it short and to the point. 9.2. What is the difference between the highest and the lowest Net ODA received per capita (current US$) of Kiribati?
Give a very brief answer. 85.45. 